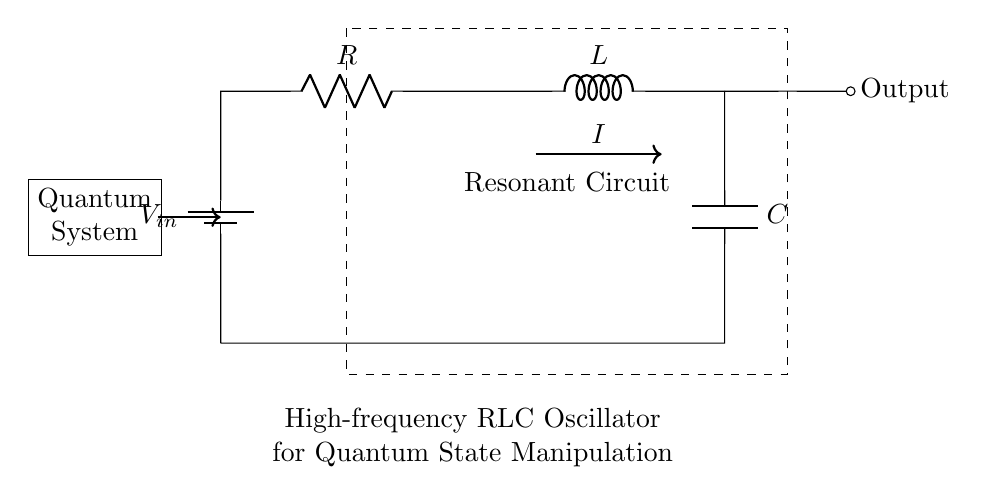What components are present in this circuit? The diagram shows three components: a resistor, an inductor, and a capacitor. These are labeled R, L, and C respectively.
Answer: Resistor, Inductor, Capacitor What does the circuit output represent? The circuit has an output labeled "Output" which typically indicates that it is providing a signal or power derived from the input voltage through the resonant circuit.
Answer: Output signal What is the role of the capacitor in this oscillator circuit? The capacitor stores electrical energy temporarily and helps define the oscillation frequency together with the inductor in this resonant circuit.
Answer: Energy storage, frequency definition Which component controls the resonant frequency of this oscillator? The resonant frequency is influenced by both the inductor and the capacitor values, as they set the rate at which the circuit can oscillate.
Answer: Inductor and Capacitor How would increasing the resistance affect the quality factor of the oscillation? Increasing the resistance typically lowers the quality factor (Q factor) of the circuit, resulting in broader resonance and less selective oscillation, which affects stability and energy losses.
Answer: Lowers quality factor What is the expected behavior of the circuit when tuning the inductor value? Tuning the inductor value changes the resonant frequency of the circuit, allowing for adjustment of the frequency at which the circuit oscillates.
Answer: Adjusts resonant frequency 